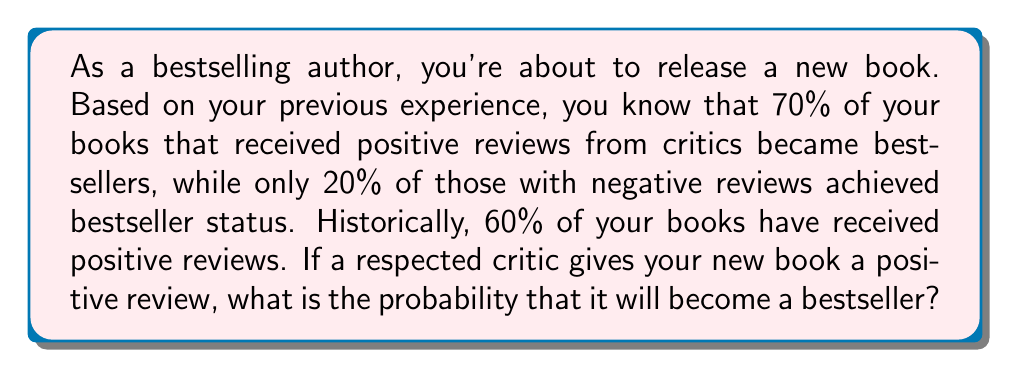Help me with this question. To solve this problem, we'll use Bayes' theorem. Let's define our events:

B: The book becomes a bestseller
P: The book receives a positive review

We're given the following probabilities:
$P(B|P) = 0.70$ (probability of bestseller given positive review)
$P(B|\neg P) = 0.20$ (probability of bestseller given negative review)
$P(P) = 0.60$ (probability of positive review)

We need to find $P(B|P)$, which is already given as 0.70. However, let's verify this using Bayes' theorem:

$$P(B|P) = \frac{P(P|B) \cdot P(B)}{P(P)}$$

To use this, we need to calculate $P(B)$ using the law of total probability:

$$P(B) = P(B|P) \cdot P(P) + P(B|\neg P) \cdot P(\neg P)$$
$$P(B) = 0.70 \cdot 0.60 + 0.20 \cdot 0.40 = 0.42 + 0.08 = 0.50$$

Now we can calculate $P(P|B)$:

$$P(P|B) = \frac{P(B|P) \cdot P(P)}{P(B)} = \frac{0.70 \cdot 0.60}{0.50} = 0.84$$

Finally, we can verify $P(B|P)$ using Bayes' theorem:

$$P(B|P) = \frac{P(P|B) \cdot P(B)}{P(P)} = \frac{0.84 \cdot 0.50}{0.60} = 0.70$$

This confirms the given probability in the question.
Answer: The probability that the book will become a bestseller given a positive review from a respected critic is 0.70 or 70%. 